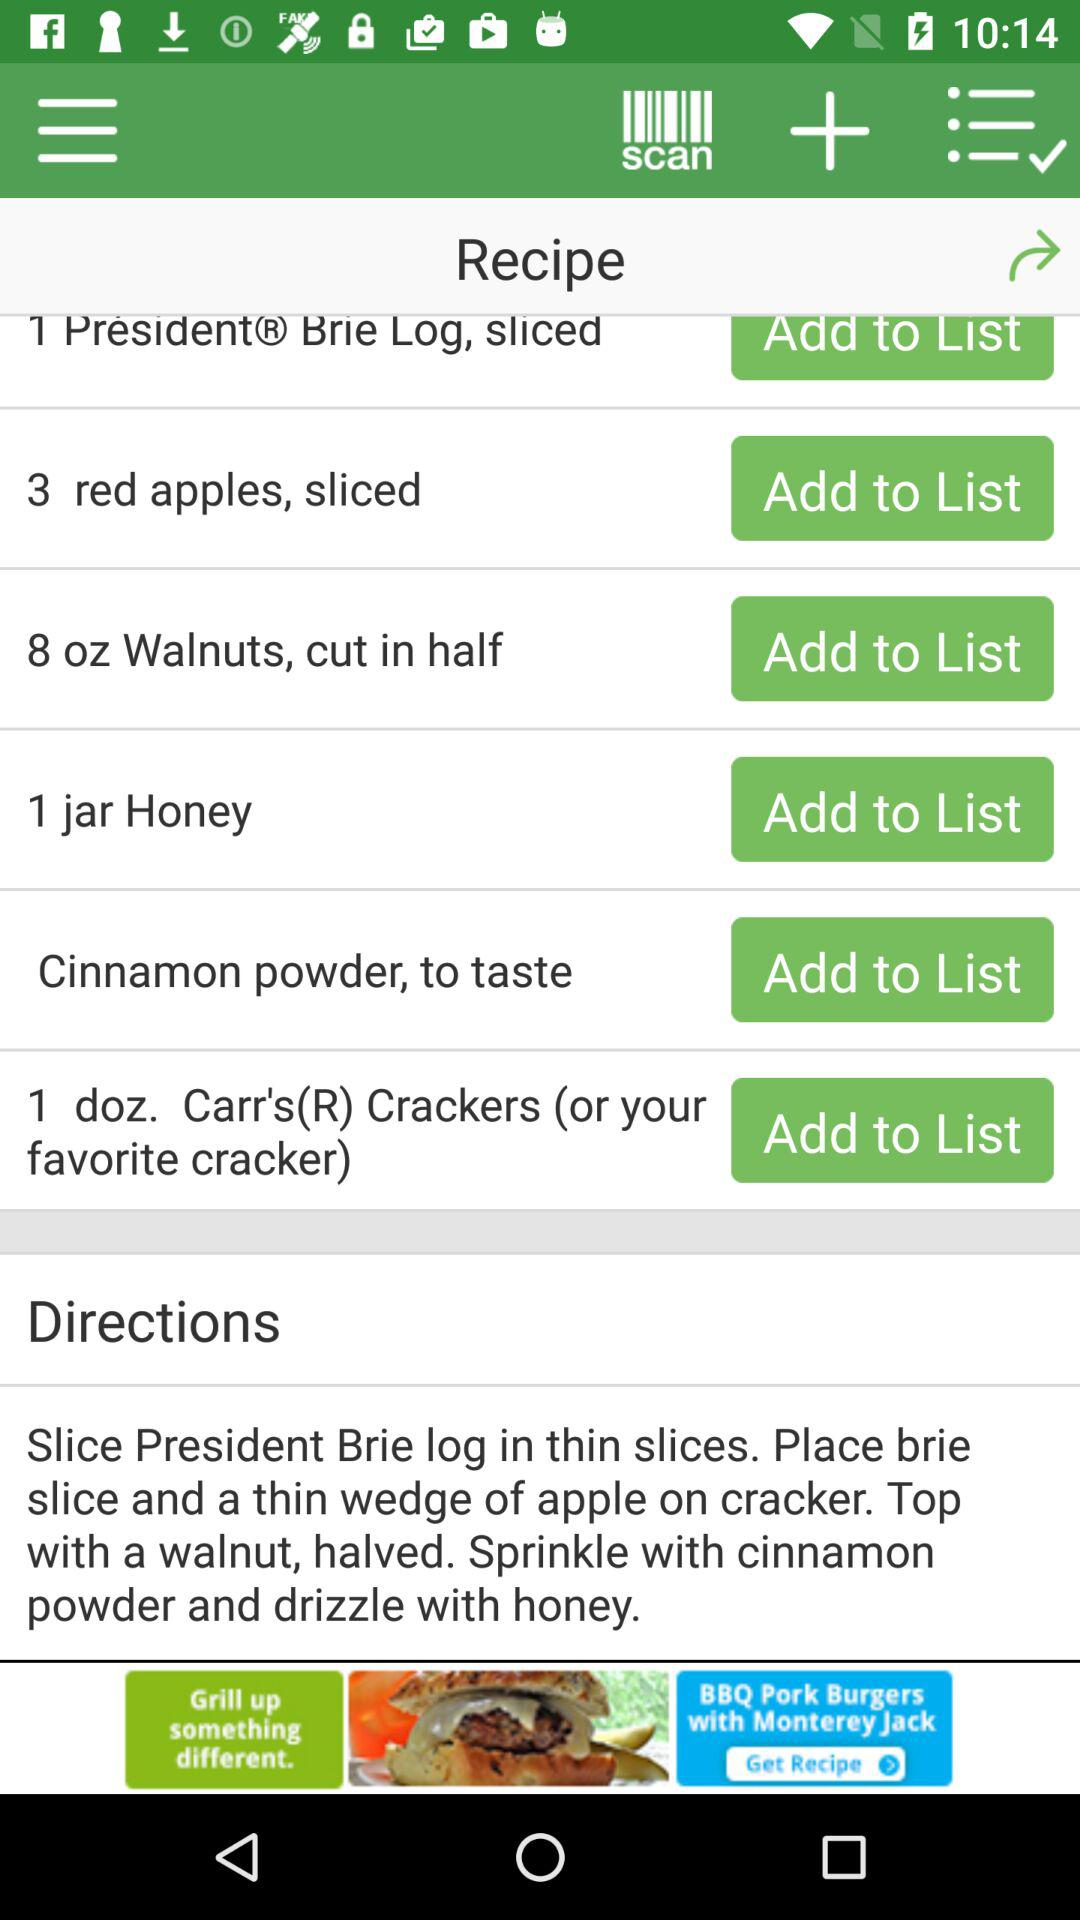How many ingredients are in the recipe?
Answer the question using a single word or phrase. 6 